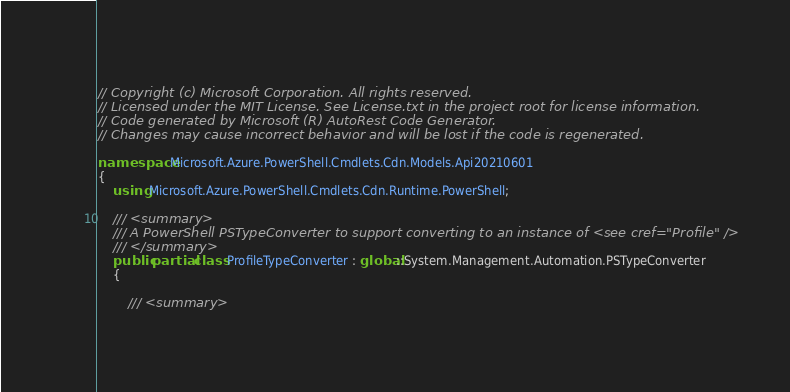<code> <loc_0><loc_0><loc_500><loc_500><_C#_>// Copyright (c) Microsoft Corporation. All rights reserved.
// Licensed under the MIT License. See License.txt in the project root for license information.
// Code generated by Microsoft (R) AutoRest Code Generator.
// Changes may cause incorrect behavior and will be lost if the code is regenerated.

namespace Microsoft.Azure.PowerShell.Cmdlets.Cdn.Models.Api20210601
{
    using Microsoft.Azure.PowerShell.Cmdlets.Cdn.Runtime.PowerShell;

    /// <summary>
    /// A PowerShell PSTypeConverter to support converting to an instance of <see cref="Profile" />
    /// </summary>
    public partial class ProfileTypeConverter : global::System.Management.Automation.PSTypeConverter
    {

        /// <summary></code> 